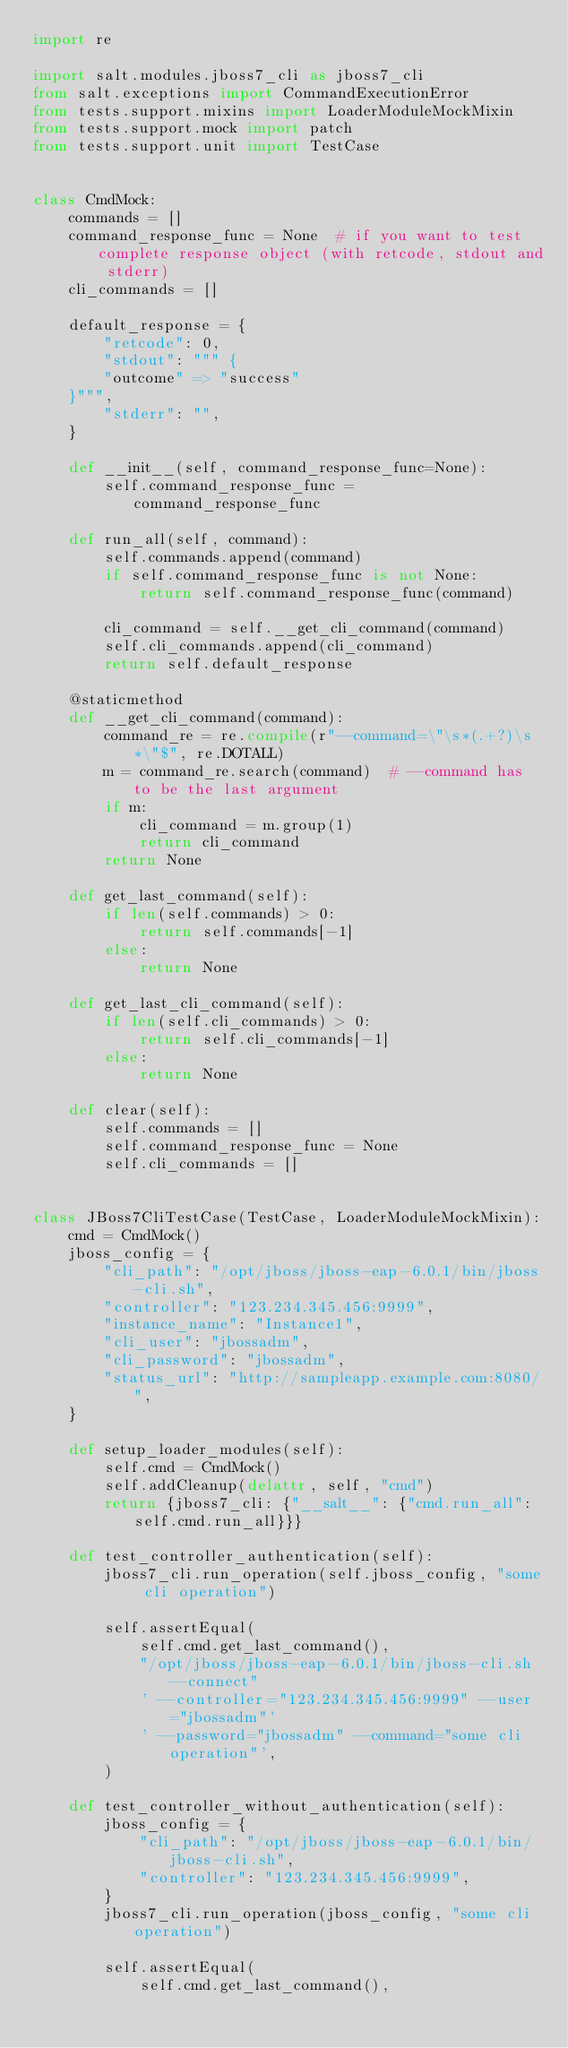Convert code to text. <code><loc_0><loc_0><loc_500><loc_500><_Python_>import re

import salt.modules.jboss7_cli as jboss7_cli
from salt.exceptions import CommandExecutionError
from tests.support.mixins import LoaderModuleMockMixin
from tests.support.mock import patch
from tests.support.unit import TestCase


class CmdMock:
    commands = []
    command_response_func = None  # if you want to test complete response object (with retcode, stdout and stderr)
    cli_commands = []

    default_response = {
        "retcode": 0,
        "stdout": """ {
        "outcome" => "success"
    }""",
        "stderr": "",
    }

    def __init__(self, command_response_func=None):
        self.command_response_func = command_response_func

    def run_all(self, command):
        self.commands.append(command)
        if self.command_response_func is not None:
            return self.command_response_func(command)

        cli_command = self.__get_cli_command(command)
        self.cli_commands.append(cli_command)
        return self.default_response

    @staticmethod
    def __get_cli_command(command):
        command_re = re.compile(r"--command=\"\s*(.+?)\s*\"$", re.DOTALL)
        m = command_re.search(command)  # --command has to be the last argument
        if m:
            cli_command = m.group(1)
            return cli_command
        return None

    def get_last_command(self):
        if len(self.commands) > 0:
            return self.commands[-1]
        else:
            return None

    def get_last_cli_command(self):
        if len(self.cli_commands) > 0:
            return self.cli_commands[-1]
        else:
            return None

    def clear(self):
        self.commands = []
        self.command_response_func = None
        self.cli_commands = []


class JBoss7CliTestCase(TestCase, LoaderModuleMockMixin):
    cmd = CmdMock()
    jboss_config = {
        "cli_path": "/opt/jboss/jboss-eap-6.0.1/bin/jboss-cli.sh",
        "controller": "123.234.345.456:9999",
        "instance_name": "Instance1",
        "cli_user": "jbossadm",
        "cli_password": "jbossadm",
        "status_url": "http://sampleapp.example.com:8080/",
    }

    def setup_loader_modules(self):
        self.cmd = CmdMock()
        self.addCleanup(delattr, self, "cmd")
        return {jboss7_cli: {"__salt__": {"cmd.run_all": self.cmd.run_all}}}

    def test_controller_authentication(self):
        jboss7_cli.run_operation(self.jboss_config, "some cli operation")

        self.assertEqual(
            self.cmd.get_last_command(),
            "/opt/jboss/jboss-eap-6.0.1/bin/jboss-cli.sh --connect"
            ' --controller="123.234.345.456:9999" --user="jbossadm"'
            ' --password="jbossadm" --command="some cli operation"',
        )

    def test_controller_without_authentication(self):
        jboss_config = {
            "cli_path": "/opt/jboss/jboss-eap-6.0.1/bin/jboss-cli.sh",
            "controller": "123.234.345.456:9999",
        }
        jboss7_cli.run_operation(jboss_config, "some cli operation")

        self.assertEqual(
            self.cmd.get_last_command(),</code> 